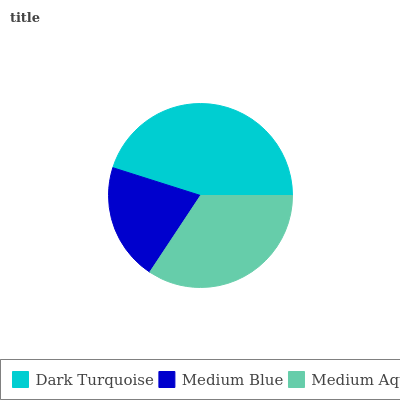Is Medium Blue the minimum?
Answer yes or no. Yes. Is Dark Turquoise the maximum?
Answer yes or no. Yes. Is Medium Aqua the minimum?
Answer yes or no. No. Is Medium Aqua the maximum?
Answer yes or no. No. Is Medium Aqua greater than Medium Blue?
Answer yes or no. Yes. Is Medium Blue less than Medium Aqua?
Answer yes or no. Yes. Is Medium Blue greater than Medium Aqua?
Answer yes or no. No. Is Medium Aqua less than Medium Blue?
Answer yes or no. No. Is Medium Aqua the high median?
Answer yes or no. Yes. Is Medium Aqua the low median?
Answer yes or no. Yes. Is Dark Turquoise the high median?
Answer yes or no. No. Is Medium Blue the low median?
Answer yes or no. No. 